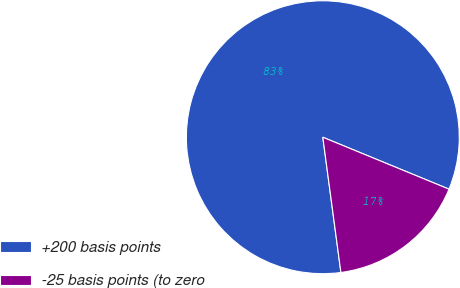Convert chart. <chart><loc_0><loc_0><loc_500><loc_500><pie_chart><fcel>+200 basis points<fcel>-25 basis points (to zero<nl><fcel>83.33%<fcel>16.67%<nl></chart> 